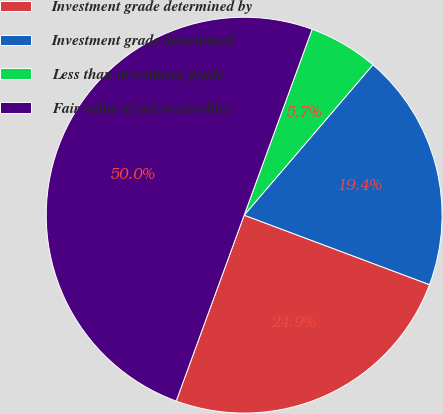Convert chart. <chart><loc_0><loc_0><loc_500><loc_500><pie_chart><fcel>Investment grade determined by<fcel>Investment grade determined<fcel>Less than investment grade<fcel>Fair value of net receivables<nl><fcel>24.87%<fcel>19.44%<fcel>5.69%<fcel>50.0%<nl></chart> 